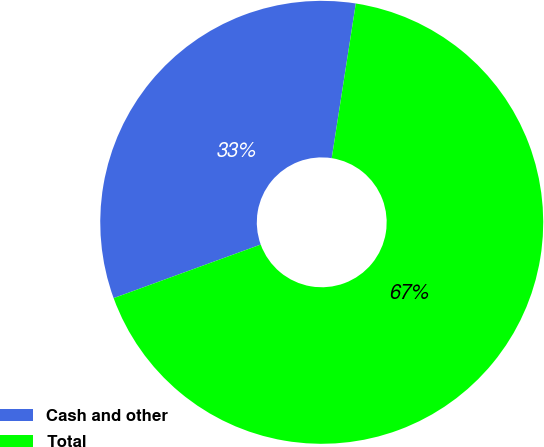Convert chart to OTSL. <chart><loc_0><loc_0><loc_500><loc_500><pie_chart><fcel>Cash and other<fcel>Total<nl><fcel>33.02%<fcel>66.98%<nl></chart> 